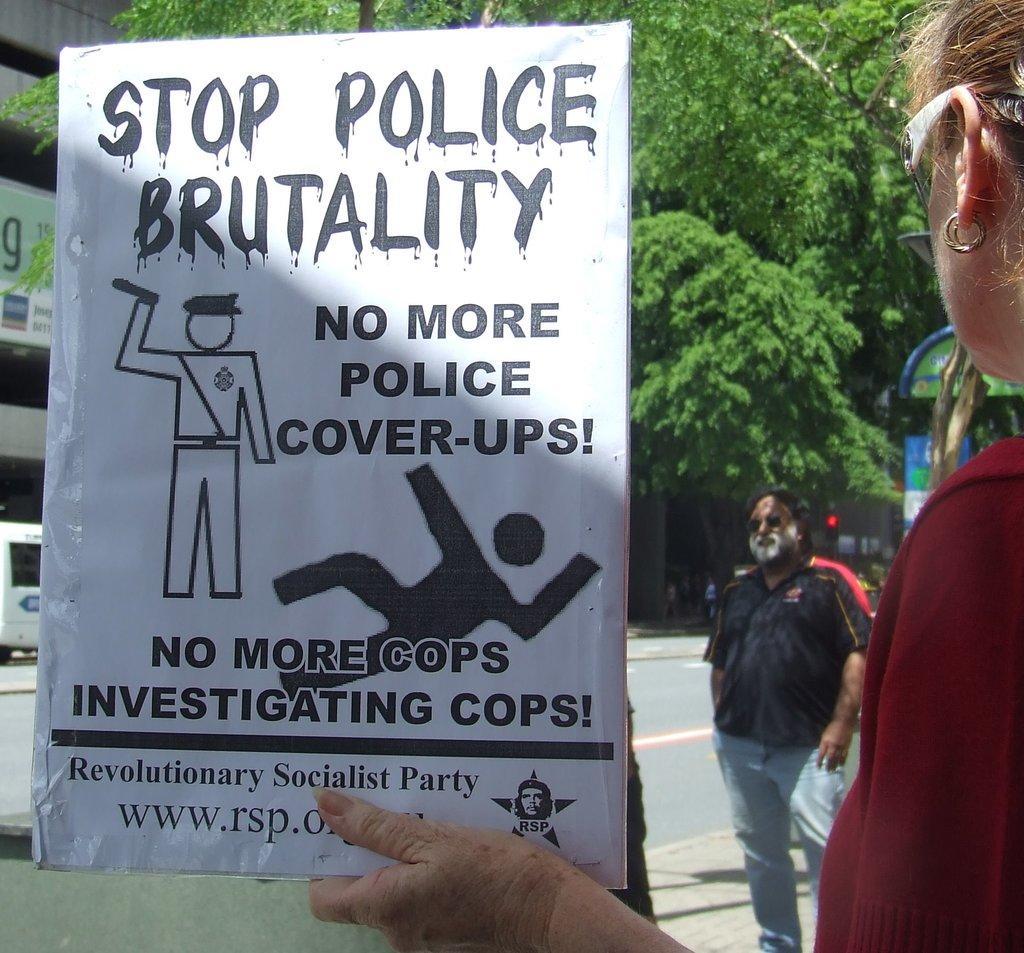In one or two sentences, can you explain what this image depicts? On the right side of this image I can see a woman wearing red color dress, holding a white color board in her hand. On this board I can see some text. In the background there is a man standing on the footpath. On the left side, I can see a white color vehicle on the road and also there is building. On the top of the image I can see the trees. 